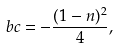Convert formula to latex. <formula><loc_0><loc_0><loc_500><loc_500>b c = - \frac { ( 1 - n ) ^ { 2 } } { 4 } ,</formula> 